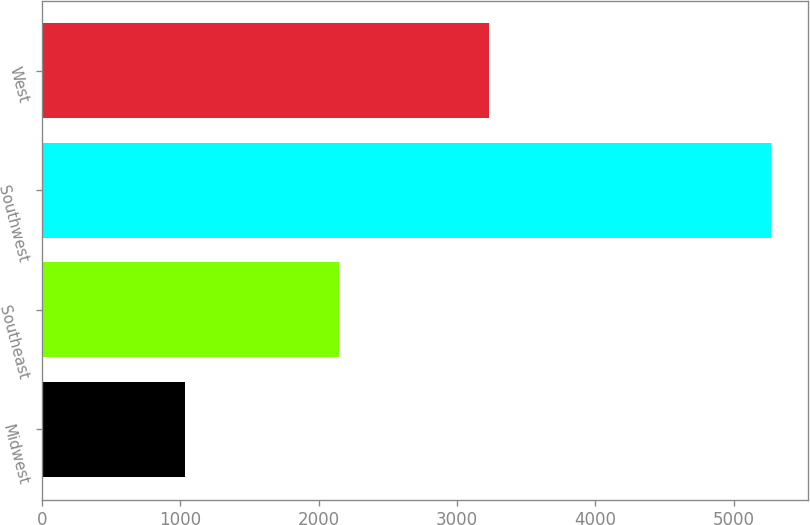<chart> <loc_0><loc_0><loc_500><loc_500><bar_chart><fcel>Midwest<fcel>Southeast<fcel>Southwest<fcel>West<nl><fcel>1037<fcel>2148<fcel>5271<fcel>3228<nl></chart> 